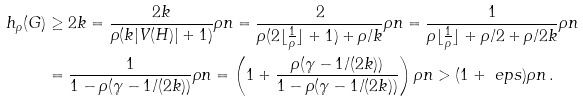<formula> <loc_0><loc_0><loc_500><loc_500>h _ { \rho } ( G ) & \geq 2 k = \frac { 2 k } { \rho ( k | V ( H ) | + 1 ) } \rho n = \frac { 2 } { \rho ( 2 \lfloor \frac { 1 } { \rho } \rfloor + 1 ) + \rho / k } \rho n = \frac { 1 } { \rho \lfloor \frac { 1 } { \rho } \rfloor + \rho / 2 + \rho / 2 k } \rho n \\ & = \frac { 1 } { 1 - \rho ( \gamma - 1 / ( 2 k ) ) } \rho n = \left ( 1 + \frac { \rho ( \gamma - 1 / ( 2 k ) ) } { 1 - \rho ( \gamma - 1 / ( 2 k ) ) } \right ) \rho n > ( 1 + \ e p s ) \rho n \, .</formula> 